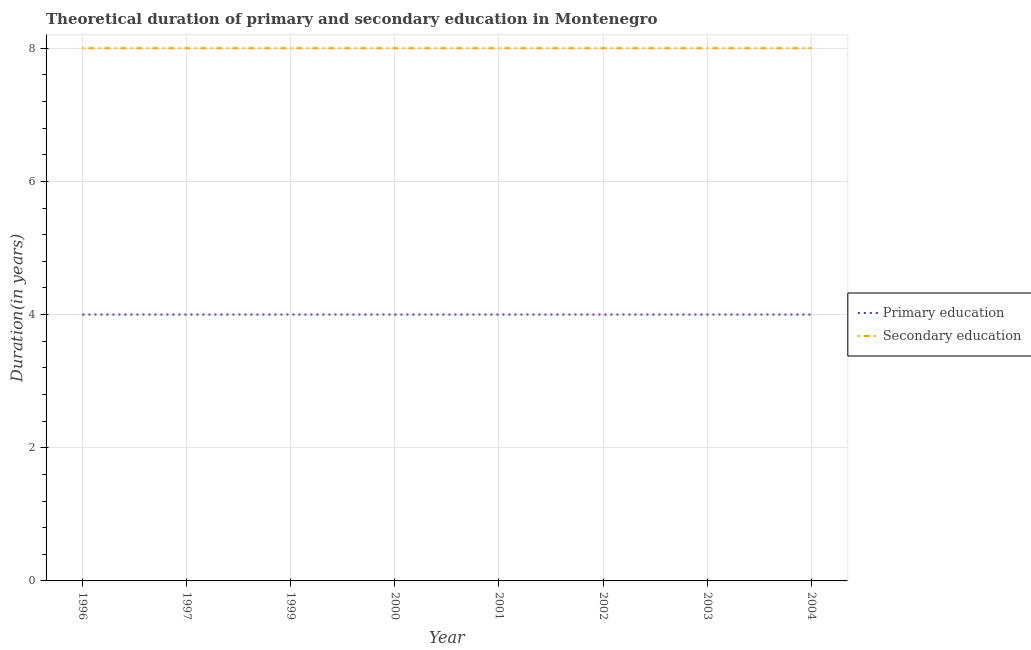What is the duration of primary education in 2003?
Provide a succinct answer. 4. Across all years, what is the maximum duration of secondary education?
Keep it short and to the point. 8. Across all years, what is the minimum duration of primary education?
Your response must be concise. 4. In which year was the duration of secondary education minimum?
Give a very brief answer. 1996. What is the total duration of primary education in the graph?
Provide a succinct answer. 32. What is the difference between the duration of secondary education in 2003 and the duration of primary education in 2000?
Provide a succinct answer. 4. In the year 2001, what is the difference between the duration of primary education and duration of secondary education?
Give a very brief answer. -4. What is the difference between the highest and the second highest duration of primary education?
Offer a very short reply. 0. Is the sum of the duration of primary education in 2001 and 2003 greater than the maximum duration of secondary education across all years?
Your answer should be very brief. No. How many lines are there?
Your answer should be very brief. 2. How many years are there in the graph?
Keep it short and to the point. 8. Does the graph contain any zero values?
Offer a terse response. No. Where does the legend appear in the graph?
Offer a terse response. Center right. How many legend labels are there?
Provide a succinct answer. 2. What is the title of the graph?
Your answer should be very brief. Theoretical duration of primary and secondary education in Montenegro. What is the label or title of the Y-axis?
Provide a succinct answer. Duration(in years). What is the Duration(in years) in Secondary education in 1996?
Your answer should be compact. 8. What is the Duration(in years) in Secondary education in 1997?
Your answer should be very brief. 8. What is the Duration(in years) in Secondary education in 1999?
Give a very brief answer. 8. What is the Duration(in years) of Secondary education in 2001?
Offer a very short reply. 8. What is the Duration(in years) of Primary education in 2002?
Ensure brevity in your answer.  4. What is the Duration(in years) of Secondary education in 2002?
Offer a terse response. 8. What is the Duration(in years) of Secondary education in 2003?
Keep it short and to the point. 8. What is the Duration(in years) in Primary education in 2004?
Ensure brevity in your answer.  4. What is the Duration(in years) of Secondary education in 2004?
Provide a succinct answer. 8. Across all years, what is the maximum Duration(in years) of Primary education?
Offer a very short reply. 4. Across all years, what is the minimum Duration(in years) in Primary education?
Provide a succinct answer. 4. What is the total Duration(in years) of Primary education in the graph?
Make the answer very short. 32. What is the difference between the Duration(in years) in Primary education in 1996 and that in 1997?
Your answer should be very brief. 0. What is the difference between the Duration(in years) in Secondary education in 1996 and that in 1999?
Make the answer very short. 0. What is the difference between the Duration(in years) of Primary education in 1996 and that in 2000?
Your answer should be very brief. 0. What is the difference between the Duration(in years) in Primary education in 1996 and that in 2001?
Make the answer very short. 0. What is the difference between the Duration(in years) of Primary education in 1996 and that in 2002?
Keep it short and to the point. 0. What is the difference between the Duration(in years) in Secondary education in 1996 and that in 2002?
Your answer should be very brief. 0. What is the difference between the Duration(in years) in Primary education in 1996 and that in 2003?
Offer a terse response. 0. What is the difference between the Duration(in years) in Primary education in 1997 and that in 1999?
Provide a short and direct response. 0. What is the difference between the Duration(in years) in Secondary education in 1997 and that in 1999?
Your answer should be compact. 0. What is the difference between the Duration(in years) of Secondary education in 1997 and that in 2001?
Offer a very short reply. 0. What is the difference between the Duration(in years) in Primary education in 1997 and that in 2003?
Keep it short and to the point. 0. What is the difference between the Duration(in years) of Secondary education in 1997 and that in 2003?
Ensure brevity in your answer.  0. What is the difference between the Duration(in years) in Primary education in 1997 and that in 2004?
Provide a short and direct response. 0. What is the difference between the Duration(in years) of Secondary education in 1997 and that in 2004?
Your answer should be compact. 0. What is the difference between the Duration(in years) in Secondary education in 1999 and that in 2000?
Your answer should be compact. 0. What is the difference between the Duration(in years) in Primary education in 1999 and that in 2001?
Give a very brief answer. 0. What is the difference between the Duration(in years) in Secondary education in 1999 and that in 2001?
Ensure brevity in your answer.  0. What is the difference between the Duration(in years) of Primary education in 1999 and that in 2002?
Make the answer very short. 0. What is the difference between the Duration(in years) of Secondary education in 1999 and that in 2003?
Give a very brief answer. 0. What is the difference between the Duration(in years) of Primary education in 2000 and that in 2001?
Your answer should be compact. 0. What is the difference between the Duration(in years) of Secondary education in 2000 and that in 2003?
Your response must be concise. 0. What is the difference between the Duration(in years) of Primary education in 2000 and that in 2004?
Make the answer very short. 0. What is the difference between the Duration(in years) in Secondary education in 2000 and that in 2004?
Your response must be concise. 0. What is the difference between the Duration(in years) of Primary education in 2001 and that in 2002?
Give a very brief answer. 0. What is the difference between the Duration(in years) in Secondary education in 2001 and that in 2002?
Your response must be concise. 0. What is the difference between the Duration(in years) in Secondary education in 2002 and that in 2003?
Give a very brief answer. 0. What is the difference between the Duration(in years) of Primary education in 2002 and that in 2004?
Your response must be concise. 0. What is the difference between the Duration(in years) in Primary education in 2003 and that in 2004?
Give a very brief answer. 0. What is the difference between the Duration(in years) of Secondary education in 2003 and that in 2004?
Provide a short and direct response. 0. What is the difference between the Duration(in years) of Primary education in 1996 and the Duration(in years) of Secondary education in 1997?
Ensure brevity in your answer.  -4. What is the difference between the Duration(in years) of Primary education in 1996 and the Duration(in years) of Secondary education in 2000?
Make the answer very short. -4. What is the difference between the Duration(in years) of Primary education in 1996 and the Duration(in years) of Secondary education in 2001?
Make the answer very short. -4. What is the difference between the Duration(in years) of Primary education in 1997 and the Duration(in years) of Secondary education in 1999?
Offer a very short reply. -4. What is the difference between the Duration(in years) in Primary education in 1997 and the Duration(in years) in Secondary education in 2001?
Your answer should be very brief. -4. What is the difference between the Duration(in years) of Primary education in 1997 and the Duration(in years) of Secondary education in 2003?
Provide a short and direct response. -4. What is the difference between the Duration(in years) in Primary education in 1997 and the Duration(in years) in Secondary education in 2004?
Make the answer very short. -4. What is the difference between the Duration(in years) in Primary education in 1999 and the Duration(in years) in Secondary education in 2000?
Provide a succinct answer. -4. What is the difference between the Duration(in years) of Primary education in 1999 and the Duration(in years) of Secondary education in 2001?
Give a very brief answer. -4. What is the difference between the Duration(in years) in Primary education in 1999 and the Duration(in years) in Secondary education in 2002?
Give a very brief answer. -4. What is the difference between the Duration(in years) in Primary education in 1999 and the Duration(in years) in Secondary education in 2003?
Provide a short and direct response. -4. What is the difference between the Duration(in years) of Primary education in 2000 and the Duration(in years) of Secondary education in 2001?
Keep it short and to the point. -4. What is the difference between the Duration(in years) of Primary education in 2000 and the Duration(in years) of Secondary education in 2003?
Offer a terse response. -4. What is the difference between the Duration(in years) of Primary education in 2000 and the Duration(in years) of Secondary education in 2004?
Provide a succinct answer. -4. What is the difference between the Duration(in years) of Primary education in 2002 and the Duration(in years) of Secondary education in 2003?
Offer a very short reply. -4. What is the difference between the Duration(in years) in Primary education in 2002 and the Duration(in years) in Secondary education in 2004?
Your answer should be compact. -4. What is the difference between the Duration(in years) of Primary education in 2003 and the Duration(in years) of Secondary education in 2004?
Offer a very short reply. -4. What is the average Duration(in years) in Primary education per year?
Your answer should be compact. 4. In the year 1996, what is the difference between the Duration(in years) of Primary education and Duration(in years) of Secondary education?
Offer a terse response. -4. In the year 1997, what is the difference between the Duration(in years) in Primary education and Duration(in years) in Secondary education?
Offer a very short reply. -4. In the year 2002, what is the difference between the Duration(in years) in Primary education and Duration(in years) in Secondary education?
Make the answer very short. -4. What is the ratio of the Duration(in years) in Primary education in 1996 to that in 1997?
Keep it short and to the point. 1. What is the ratio of the Duration(in years) of Secondary education in 1996 to that in 1999?
Offer a terse response. 1. What is the ratio of the Duration(in years) in Primary education in 1996 to that in 2000?
Your answer should be compact. 1. What is the ratio of the Duration(in years) of Primary education in 1996 to that in 2001?
Give a very brief answer. 1. What is the ratio of the Duration(in years) of Primary education in 1996 to that in 2002?
Your response must be concise. 1. What is the ratio of the Duration(in years) in Secondary education in 1997 to that in 1999?
Offer a very short reply. 1. What is the ratio of the Duration(in years) in Primary education in 1997 to that in 2000?
Provide a succinct answer. 1. What is the ratio of the Duration(in years) in Primary education in 1997 to that in 2002?
Your answer should be compact. 1. What is the ratio of the Duration(in years) in Secondary education in 1997 to that in 2002?
Provide a succinct answer. 1. What is the ratio of the Duration(in years) in Primary education in 1997 to that in 2003?
Offer a very short reply. 1. What is the ratio of the Duration(in years) of Secondary education in 1997 to that in 2004?
Offer a terse response. 1. What is the ratio of the Duration(in years) of Primary education in 1999 to that in 2002?
Your response must be concise. 1. What is the ratio of the Duration(in years) of Primary education in 1999 to that in 2003?
Your answer should be very brief. 1. What is the ratio of the Duration(in years) of Secondary education in 2000 to that in 2001?
Give a very brief answer. 1. What is the ratio of the Duration(in years) of Primary education in 2000 to that in 2003?
Your answer should be compact. 1. What is the ratio of the Duration(in years) of Secondary education in 2000 to that in 2003?
Give a very brief answer. 1. What is the ratio of the Duration(in years) in Primary education in 2000 to that in 2004?
Provide a succinct answer. 1. What is the ratio of the Duration(in years) of Secondary education in 2002 to that in 2004?
Offer a terse response. 1. What is the ratio of the Duration(in years) in Secondary education in 2003 to that in 2004?
Your answer should be very brief. 1. What is the difference between the highest and the second highest Duration(in years) of Secondary education?
Make the answer very short. 0. What is the difference between the highest and the lowest Duration(in years) in Secondary education?
Keep it short and to the point. 0. 